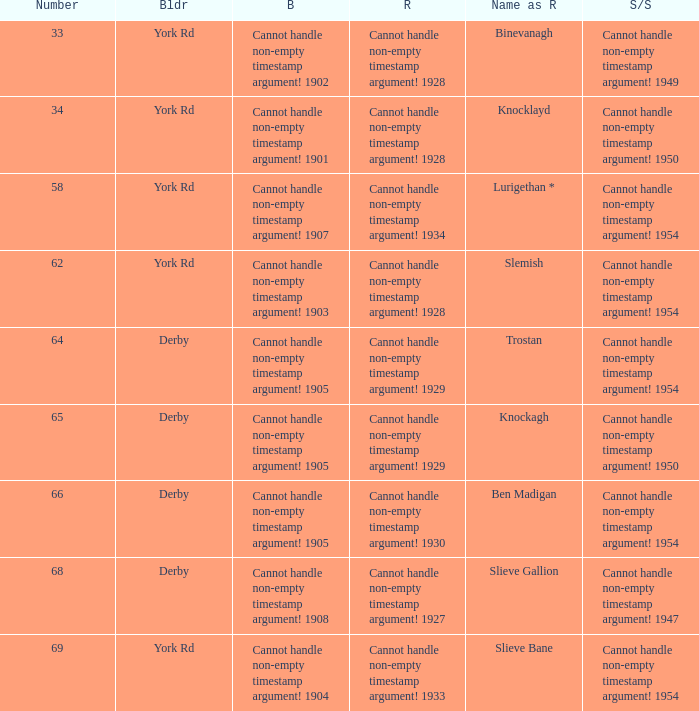Which Scrapped/Sold has a Builder of derby, and a Name as rebuilt of ben madigan? Cannot handle non-empty timestamp argument! 1954. 